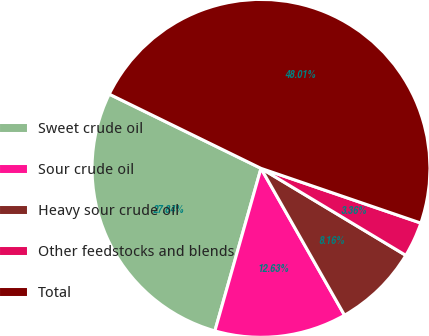Convert chart to OTSL. <chart><loc_0><loc_0><loc_500><loc_500><pie_chart><fcel>Sweet crude oil<fcel>Sour crude oil<fcel>Heavy sour crude oil<fcel>Other feedstocks and blends<fcel>Total<nl><fcel>27.84%<fcel>12.63%<fcel>8.16%<fcel>3.36%<fcel>48.01%<nl></chart> 